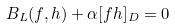<formula> <loc_0><loc_0><loc_500><loc_500>B _ { L } ( f , h ) + \alpha [ f h ] _ { D } = 0</formula> 